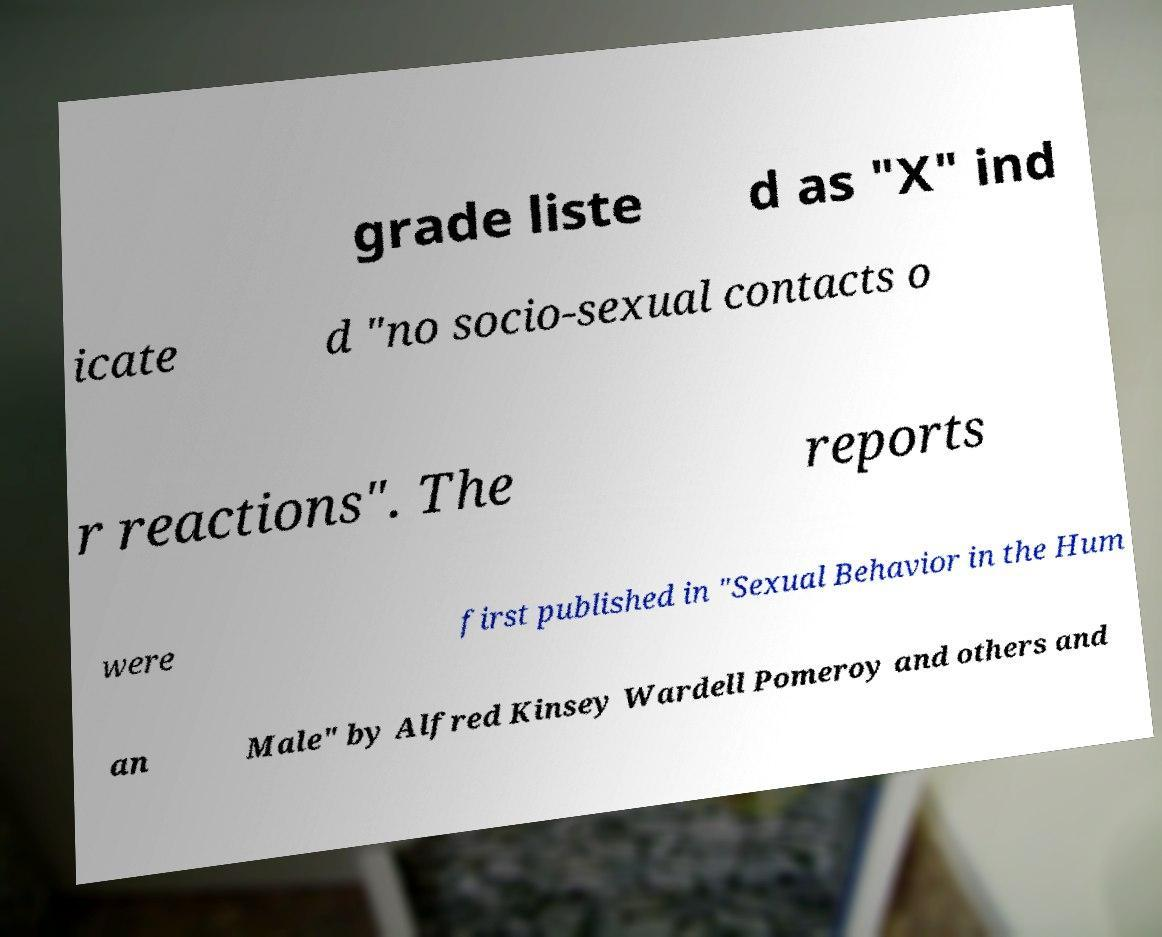Please read and relay the text visible in this image. What does it say? grade liste d as "X" ind icate d "no socio-sexual contacts o r reactions". The reports were first published in "Sexual Behavior in the Hum an Male" by Alfred Kinsey Wardell Pomeroy and others and 